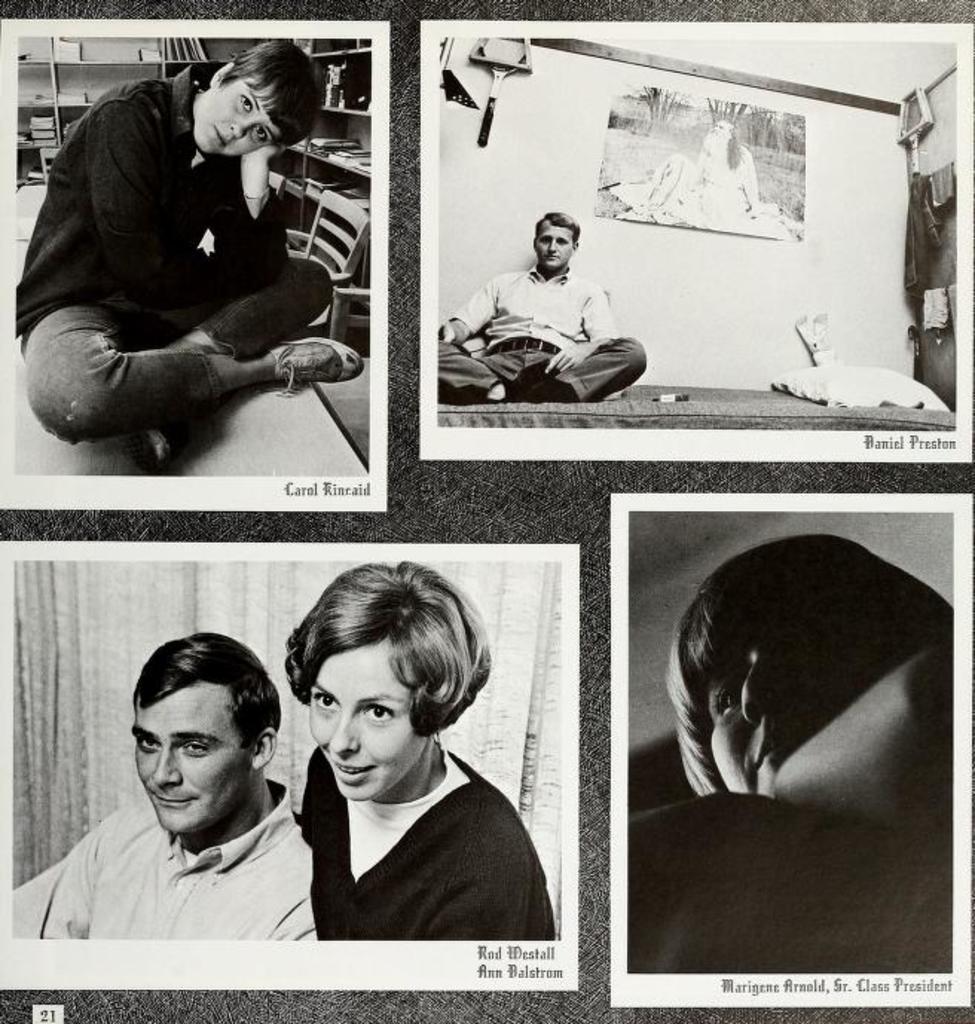In one or two sentences, can you explain what this image depicts? In the picture I can see the collage images. I can see a person sitting on the table on the top left side of the picture. I can see a man sitting on the mattress and there is a pillow on the mattress. I can see a man and a woman on the bottom left side of the image. I can see another woman on the right side. 